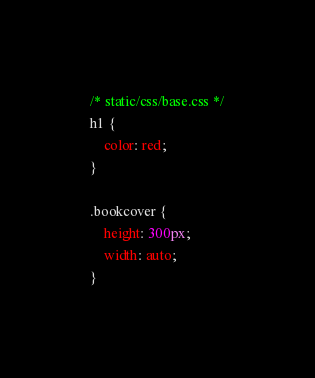Convert code to text. <code><loc_0><loc_0><loc_500><loc_500><_CSS_>/* static/css/base.css */
h1 {
    color: red;
}

.bookcover {
    height: 300px;
    width: auto;
}</code> 